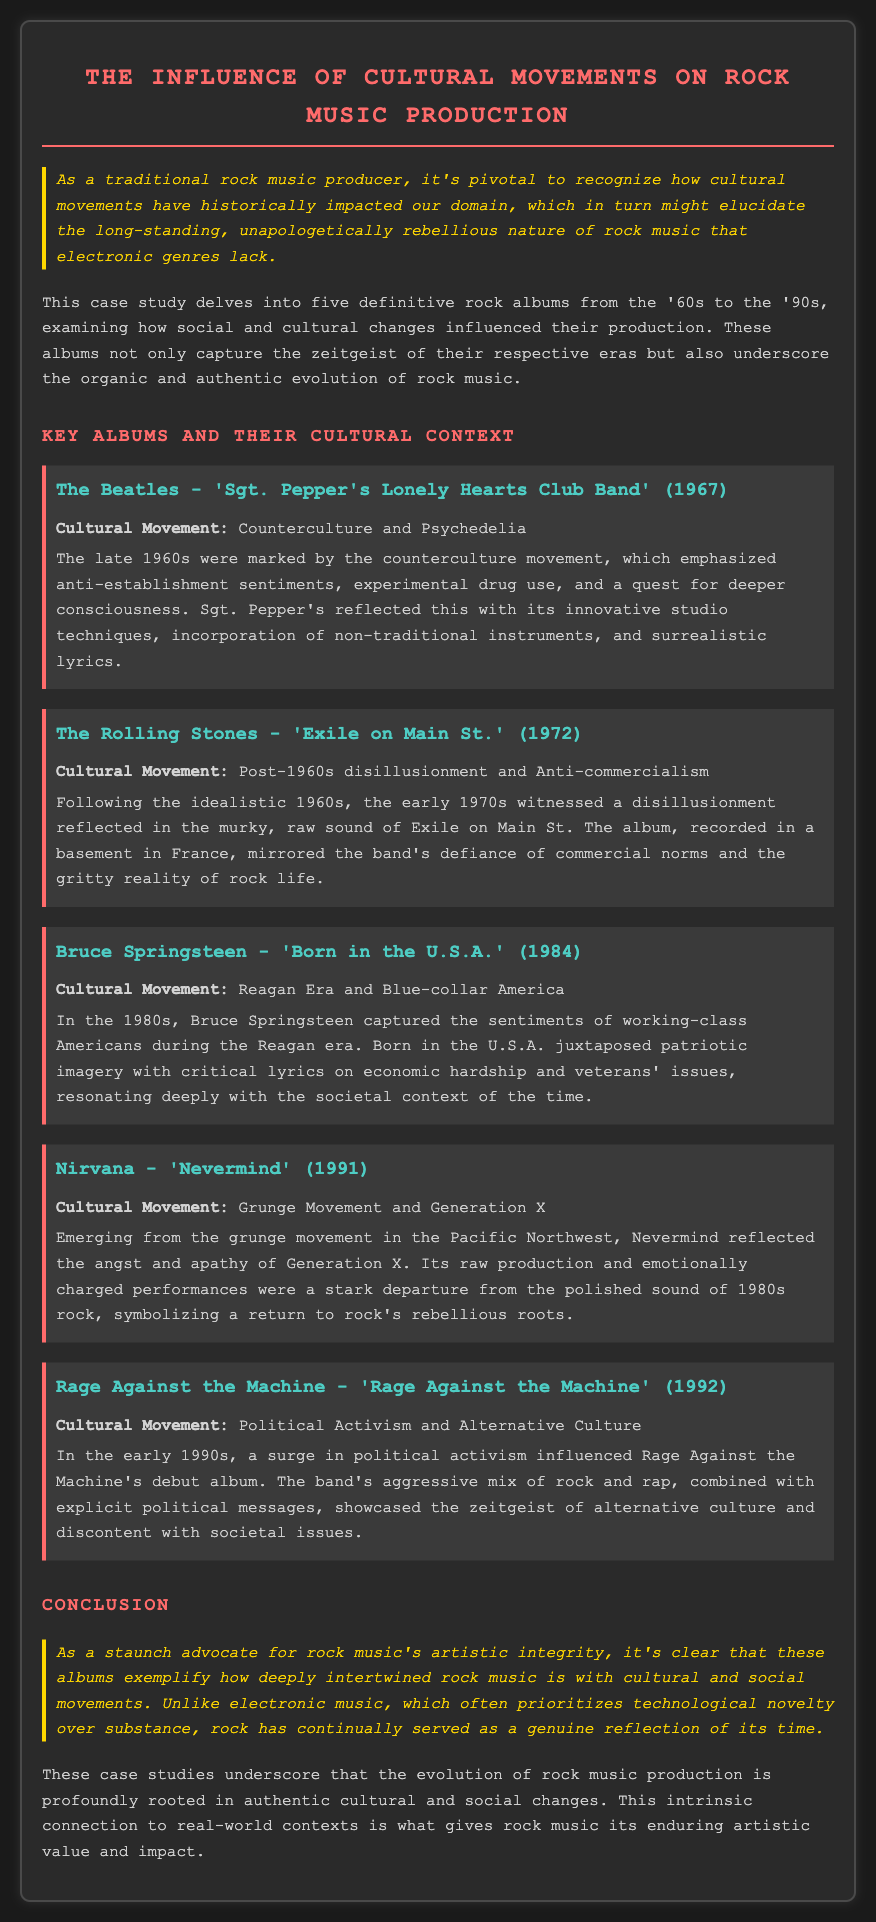What is the title of the case study? The title is prominently displayed at the top of the document, summarizing the focus on cultural movements in rock music production.
Answer: The Influence of Cultural Movements on Rock Music Production What album was released by The Beatles in 1967? The album title appears under The Beatles' section, indicating its significance within the context of the cultural movement discussed.
Answer: Sgt. Pepper's Lonely Hearts Club Band Which cultural movement influenced 'Exile on Main St.'? The cultural movement is specified in the description of the album, providing context for its themes and musical style.
Answer: Post-1960s disillusionment and Anti-commercialism What year was 'Born in the U.S.A.' released? This date is mentioned alongside the album title to highlight its historical context and relevance to the cultural movements of the time.
Answer: 1984 Which band is associated with the grunge movement? This band is clearly identified in the context of discussing the changes in rock music during the 1990s and the influence of that cultural movement.
Answer: Nirvana How many albums are examined in the case study? The document outlines five key albums, indicating the breadth of the case study’s examination of rock music's evolution.
Answer: Five What is stated as the primary comparison between rock and electronic music in the conclusion? The conclusion reinforces a perspective on the artistic integrity of rock music compared to electronic music, a recurring theme in the document.
Answer: Technological novelty over substance Which album reflects the sentiments of working-class Americans during the Reagan era? The specific reference to this album in the context of its themes provides a clear question regarding cultural relevance.
Answer: Born in the U.S.A What is a characteristic feature of 'Nevermind' as mentioned in the document? The document describes its production quality and emotional tone, emphasizing the stark contrasts with preceding eras.
Answer: Raw production and emotionally charged performances 